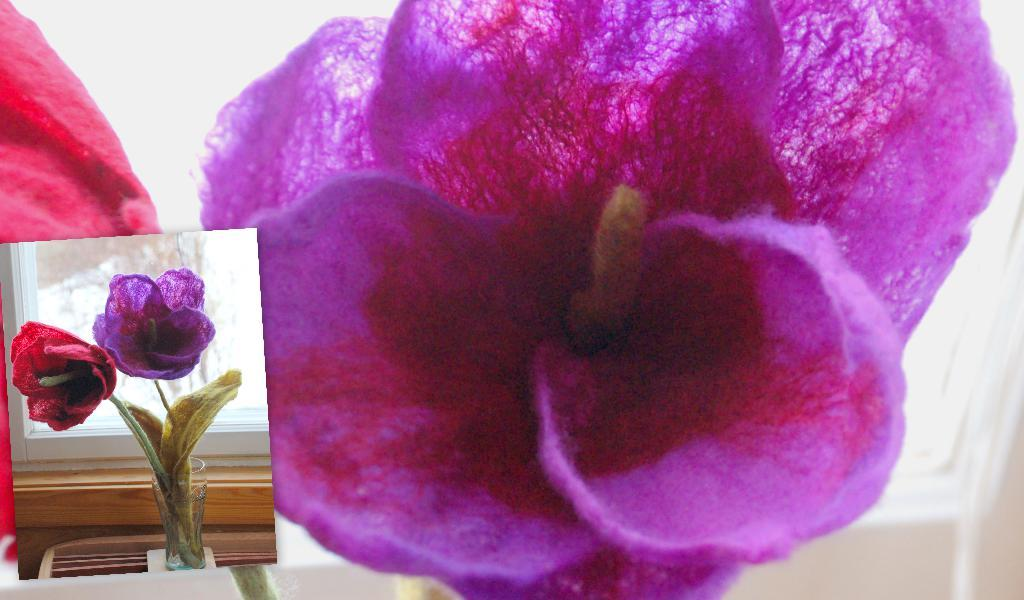What type of objects are depicted in the images in the picture? The images contain pictures of flowers. How are the flowers displayed in the image? The flowers are in a glass. What is the glass used for in the image? The glass is a window. Are there any chains hanging from the window in the image? There are no chains visible in the image; it only contains pictures of flowers in a glass window. 